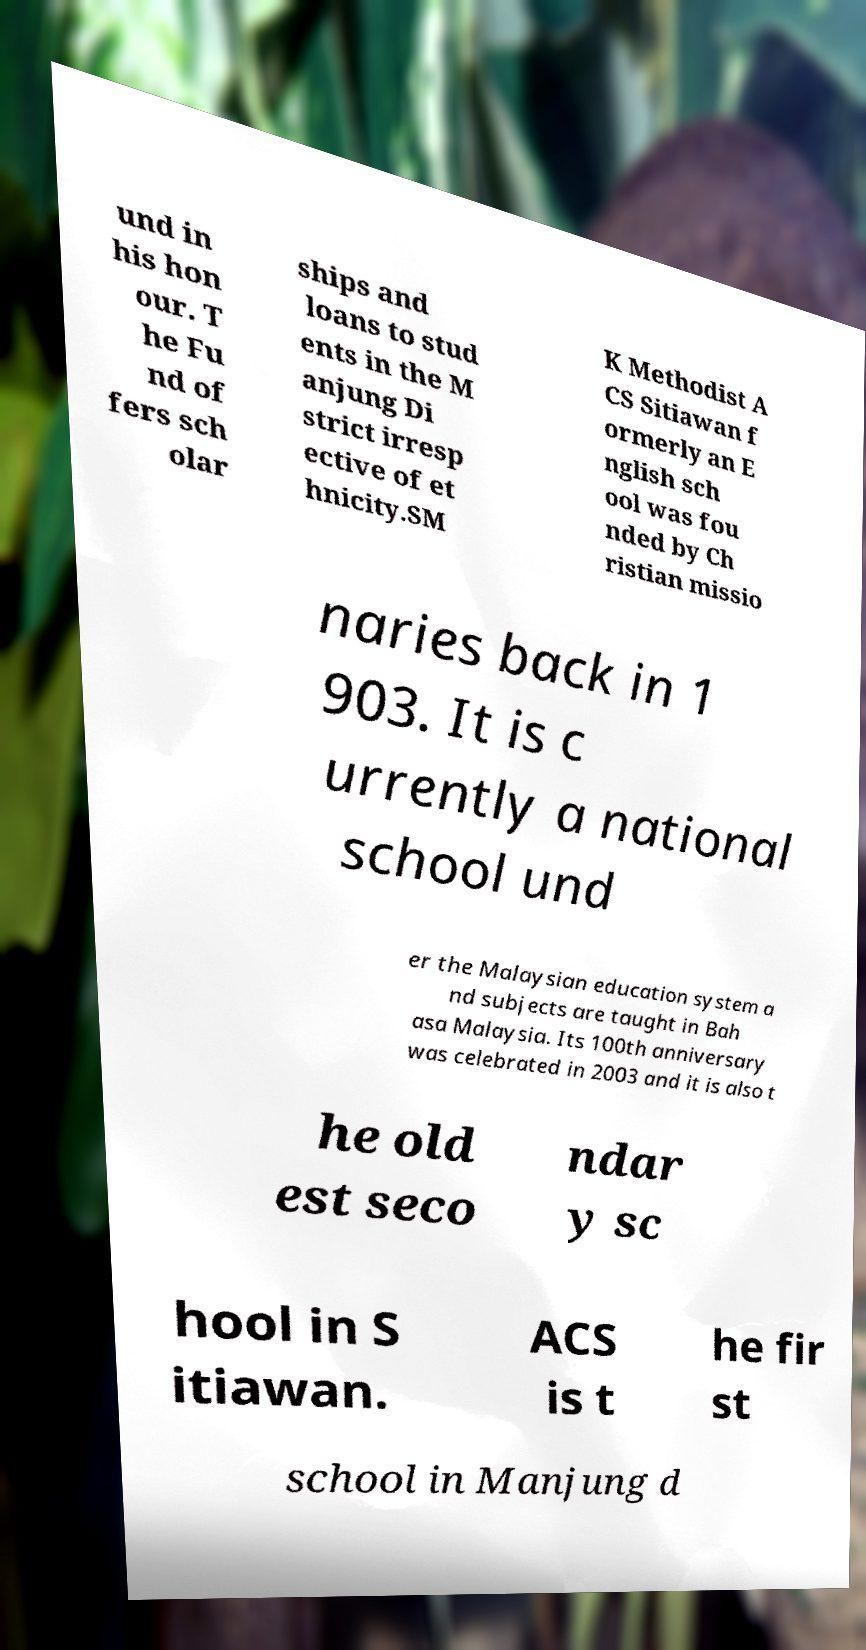Can you read and provide the text displayed in the image?This photo seems to have some interesting text. Can you extract and type it out for me? und in his hon our. T he Fu nd of fers sch olar ships and loans to stud ents in the M anjung Di strict irresp ective of et hnicity.SM K Methodist A CS Sitiawan f ormerly an E nglish sch ool was fou nded by Ch ristian missio naries back in 1 903. It is c urrently a national school und er the Malaysian education system a nd subjects are taught in Bah asa Malaysia. Its 100th anniversary was celebrated in 2003 and it is also t he old est seco ndar y sc hool in S itiawan. ACS is t he fir st school in Manjung d 